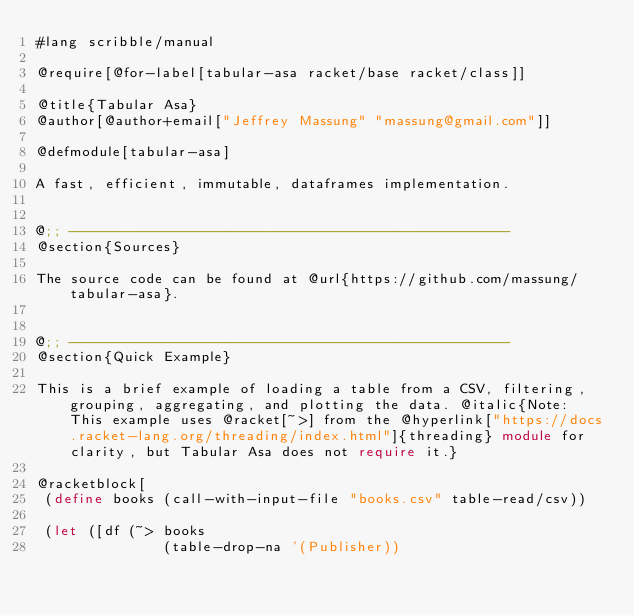<code> <loc_0><loc_0><loc_500><loc_500><_Racket_>#lang scribble/manual

@require[@for-label[tabular-asa racket/base racket/class]]

@title{Tabular Asa}
@author[@author+email["Jeffrey Massung" "massung@gmail.com"]]

@defmodule[tabular-asa]

A fast, efficient, immutable, dataframes implementation.


@;; ----------------------------------------------------
@section{Sources}

The source code can be found at @url{https://github.com/massung/tabular-asa}.


@;; ----------------------------------------------------
@section{Quick Example}

This is a brief example of loading a table from a CSV, filtering, grouping, aggregating, and plotting the data. @italic{Note: This example uses @racket[~>] from the @hyperlink["https://docs.racket-lang.org/threading/index.html"]{threading} module for clarity, but Tabular Asa does not require it.}

@racketblock[
 (define books (call-with-input-file "books.csv" table-read/csv))

 (let ([df (~> books
               (table-drop-na '(Publisher))</code> 